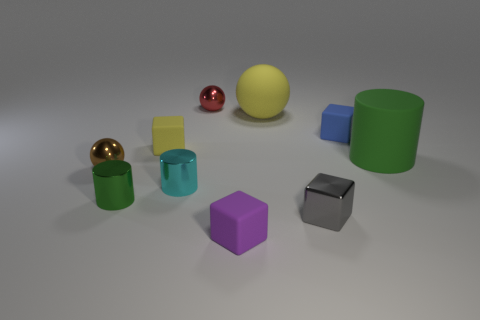There is a large rubber thing behind the blue matte block; is its color the same as the matte object left of the small cyan shiny thing?
Keep it short and to the point. Yes. Is the number of cubes to the left of the small gray thing greater than the number of small red metallic things that are right of the small red shiny thing?
Your answer should be very brief. Yes. What material is the tiny blue cube?
Ensure brevity in your answer.  Rubber. There is a green thing right of the sphere that is right of the tiny metal ball behind the yellow sphere; what shape is it?
Offer a very short reply. Cylinder. How many other objects are the same material as the tiny cyan object?
Offer a very short reply. 4. Does the big thing that is on the left side of the big green cylinder have the same material as the tiny cyan cylinder behind the purple rubber block?
Keep it short and to the point. No. How many matte things are behind the green rubber object and to the right of the tiny red metallic object?
Give a very brief answer. 2. Are there any green matte things of the same shape as the small green metal object?
Offer a terse response. Yes. There is a brown thing that is the same size as the red object; what is its shape?
Give a very brief answer. Sphere. Is the number of tiny yellow rubber things that are on the left side of the large yellow thing the same as the number of objects in front of the gray metallic cube?
Give a very brief answer. Yes. 